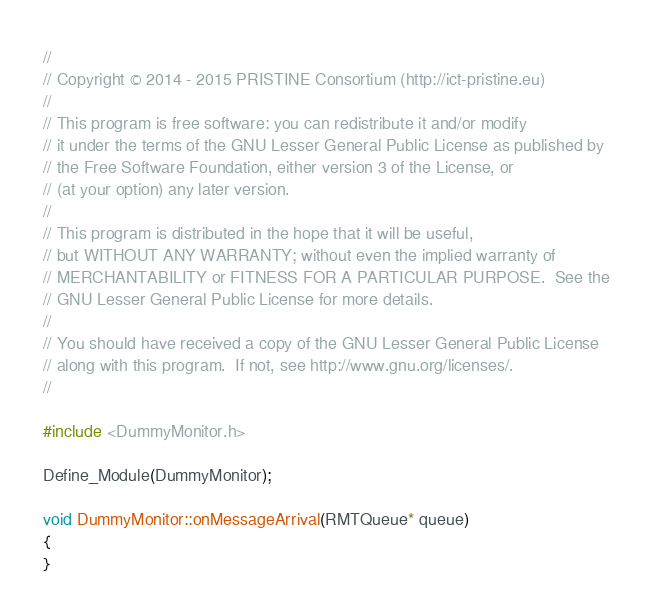<code> <loc_0><loc_0><loc_500><loc_500><_C++_>//
// Copyright © 2014 - 2015 PRISTINE Consortium (http://ict-pristine.eu)
//
// This program is free software: you can redistribute it and/or modify
// it under the terms of the GNU Lesser General Public License as published by
// the Free Software Foundation, either version 3 of the License, or
// (at your option) any later version.
//
// This program is distributed in the hope that it will be useful,
// but WITHOUT ANY WARRANTY; without even the implied warranty of
// MERCHANTABILITY or FITNESS FOR A PARTICULAR PURPOSE.  See the
// GNU Lesser General Public License for more details.
//
// You should have received a copy of the GNU Lesser General Public License
// along with this program.  If not, see http://www.gnu.org/licenses/.
//

#include <DummyMonitor.h>

Define_Module(DummyMonitor);

void DummyMonitor::onMessageArrival(RMTQueue* queue)
{
}

</code> 